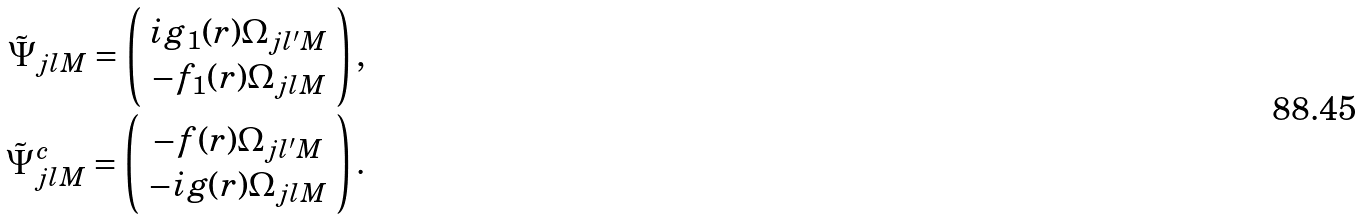<formula> <loc_0><loc_0><loc_500><loc_500>\tilde { \Psi } _ { j l M } = \left ( \begin{array} { c } i g _ { 1 } ( r ) \Omega _ { j l ^ { \prime } M } \\ - f _ { 1 } ( r ) \Omega _ { j l M } \end{array} \right ) , \\ \tilde { \Psi } ^ { c } _ { j l M } = \left ( \begin{array} { c } - f ( r ) \Omega _ { j l ^ { \prime } M } \\ - i g ( r ) \Omega _ { j l M } \end{array} \right ) .</formula> 